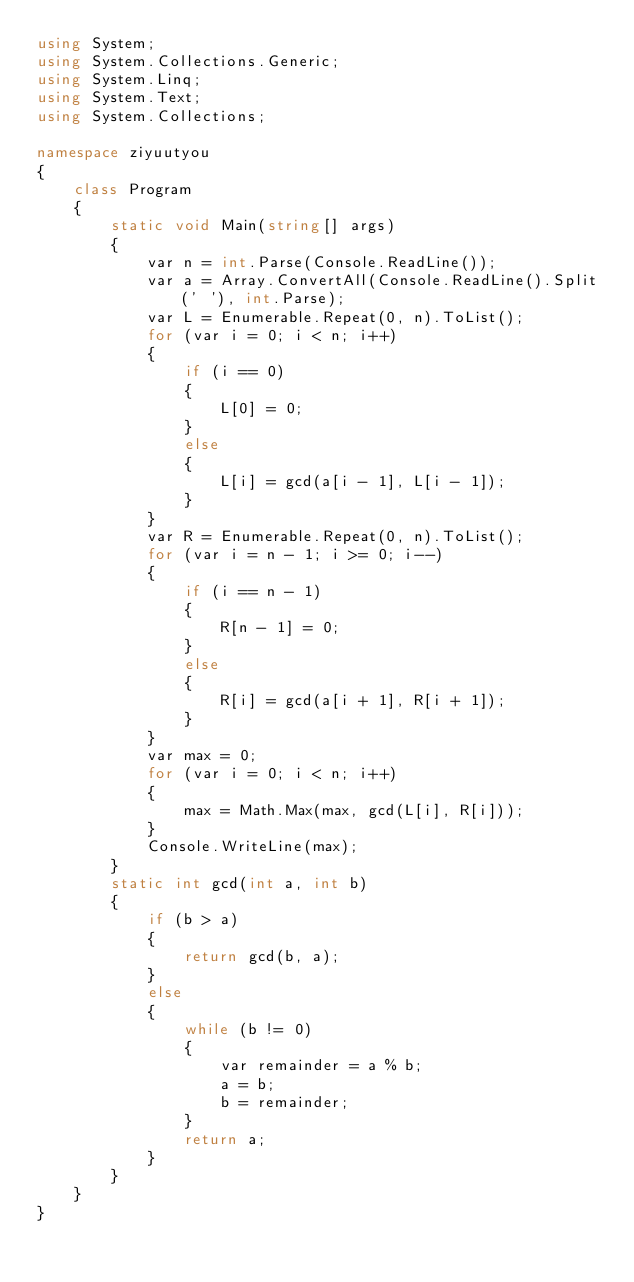<code> <loc_0><loc_0><loc_500><loc_500><_C#_>using System;
using System.Collections.Generic;
using System.Linq;
using System.Text;
using System.Collections;

namespace ziyuutyou
{
    class Program
    {
        static void Main(string[] args)
        {
            var n = int.Parse(Console.ReadLine());
            var a = Array.ConvertAll(Console.ReadLine().Split(' '), int.Parse);
            var L = Enumerable.Repeat(0, n).ToList();
            for (var i = 0; i < n; i++)
            {
                if (i == 0)
                {
                    L[0] = 0;
                }
                else
                {
                    L[i] = gcd(a[i - 1], L[i - 1]);
                }
            }
            var R = Enumerable.Repeat(0, n).ToList();
            for (var i = n - 1; i >= 0; i--)
            {
                if (i == n - 1)
                {
                    R[n - 1] = 0;
                }
                else
                {
                    R[i] = gcd(a[i + 1], R[i + 1]);
                }
            }
            var max = 0;
            for (var i = 0; i < n; i++)
            {
                max = Math.Max(max, gcd(L[i], R[i]));
            }
            Console.WriteLine(max);
        }
        static int gcd(int a, int b)
        {
            if (b > a)
            {
                return gcd(b, a);
            }
            else
            {
                while (b != 0)
                {
                    var remainder = a % b;
                    a = b;
                    b = remainder;
                }
                return a;
            }
        }
    }
}</code> 